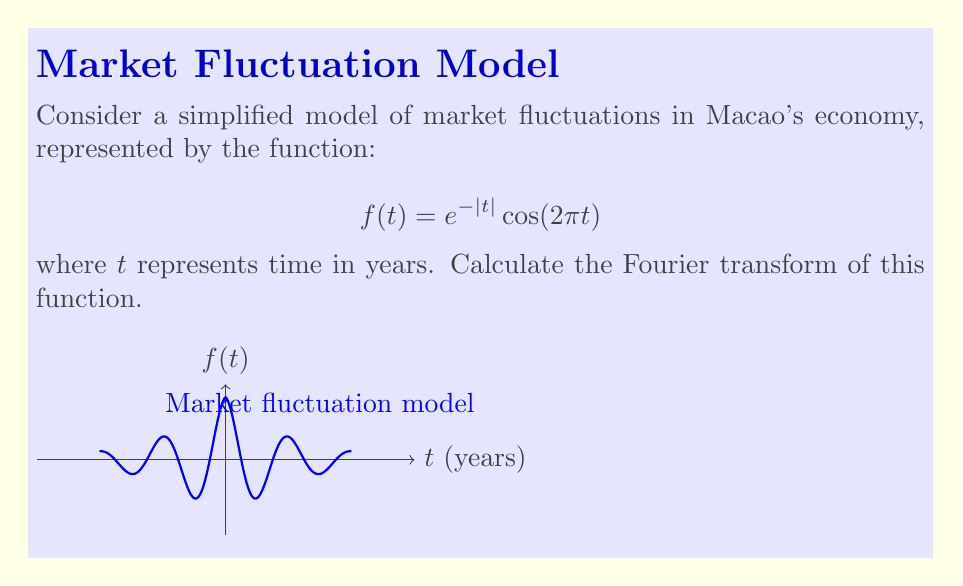Teach me how to tackle this problem. To calculate the Fourier transform of $f(t) = e^{-|t|} \cos(2\pi t)$, we follow these steps:

1) The Fourier transform is defined as:
   $$F(\omega) = \int_{-\infty}^{\infty} f(t) e^{-i\omega t} dt$$

2) Substituting our function:
   $$F(\omega) = \int_{-\infty}^{\infty} e^{-|t|} \cos(2\pi t) e^{-i\omega t} dt$$

3) Using Euler's formula, $\cos(2\pi t) = \frac{1}{2}(e^{2\pi i t} + e^{-2\pi i t})$:
   $$F(\omega) = \frac{1}{2} \int_{-\infty}^{\infty} e^{-|t|} (e^{2\pi i t} + e^{-2\pi i t}) e^{-i\omega t} dt$$

4) Simplify:
   $$F(\omega) = \frac{1}{2} \int_{-\infty}^{\infty} e^{-|t|} (e^{i(2\pi-\omega)t} + e^{-i(2\pi+\omega)t}) dt$$

5) Split the integral:
   $$F(\omega) = \frac{1}{2} \int_{-\infty}^{0} e^{t} (e^{i(2\pi-\omega)t} + e^{-i(2\pi+\omega)t}) dt + \frac{1}{2} \int_{0}^{\infty} e^{-t} (e^{i(2\pi-\omega)t} + e^{-i(2\pi+\omega)t}) dt$$

6) Evaluate each integral:
   $$F(\omega) = \frac{1}{2} \left[\frac{1}{1-i(2\pi-\omega)} + \frac{1}{1+i(2\pi+\omega)}\right] + \frac{1}{2} \left[\frac{1}{1+i(2\pi-\omega)} + \frac{1}{1-i(2\pi+\omega)}\right]$$

7) Simplify and combine terms:
   $$F(\omega) = \frac{1}{1+(2\pi-\omega)^2} + \frac{1}{1+(2\pi+\omega)^2}$$

This is the Fourier transform of the given market fluctuation function.
Answer: $$F(\omega) = \frac{1}{1+(2\pi-\omega)^2} + \frac{1}{1+(2\pi+\omega)^2}$$ 